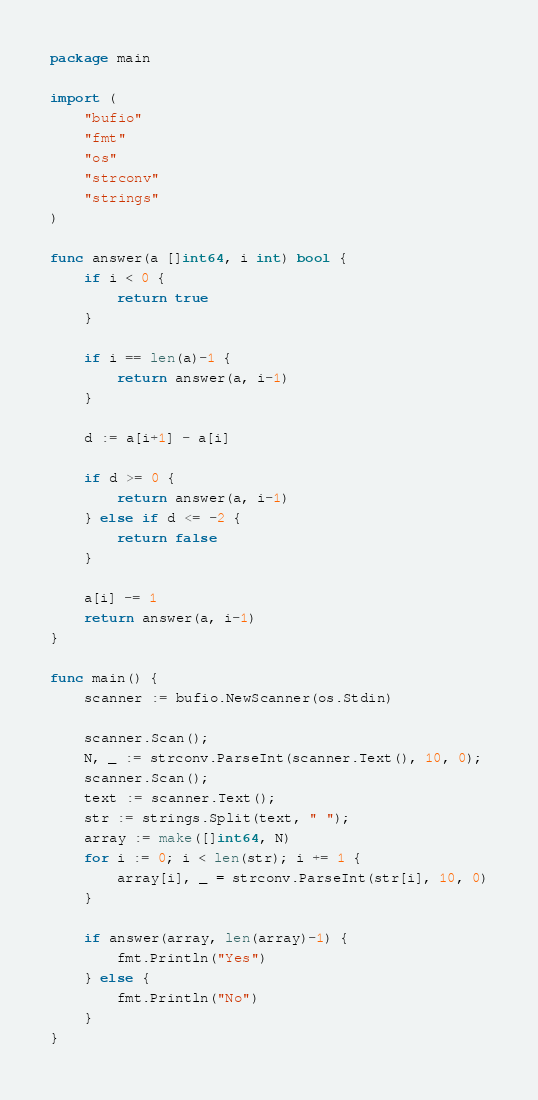<code> <loc_0><loc_0><loc_500><loc_500><_Go_>package main

import (
	"bufio"
	"fmt"
	"os"
	"strconv"
	"strings"
)

func answer(a []int64, i int) bool {
	if i < 0 {
		return true
	}

	if i == len(a)-1 {
		return answer(a, i-1)
	}

	d := a[i+1] - a[i]

	if d >= 0 {
		return answer(a, i-1)
	} else if d <= -2 {
		return false
	}

	a[i] -= 1
	return answer(a, i-1)
}

func main() {
	scanner := bufio.NewScanner(os.Stdin)

	scanner.Scan();
	N, _ := strconv.ParseInt(scanner.Text(), 10, 0);
	scanner.Scan();
	text := scanner.Text();
	str := strings.Split(text, " ");
	array := make([]int64, N)
	for i := 0; i < len(str); i += 1 {
		array[i], _ = strconv.ParseInt(str[i], 10, 0)
	}

	if answer(array, len(array)-1) {
		fmt.Println("Yes")
	} else {
		fmt.Println("No")
	}
}
</code> 